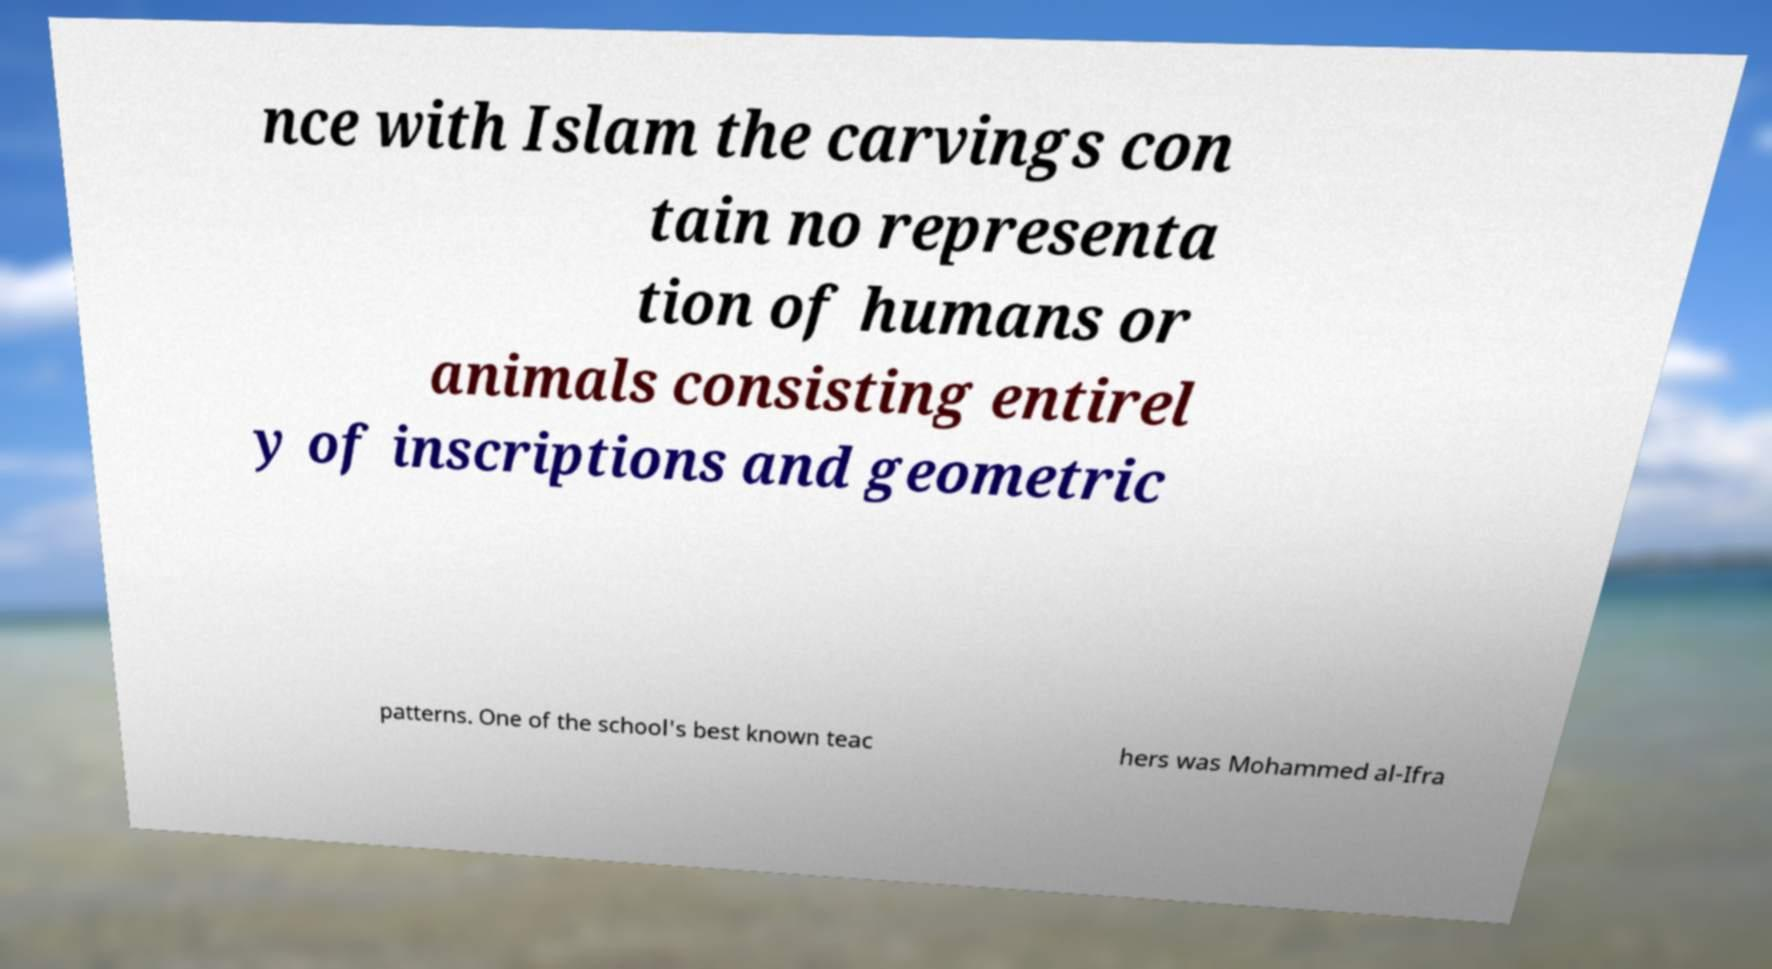Could you assist in decoding the text presented in this image and type it out clearly? nce with Islam the carvings con tain no representa tion of humans or animals consisting entirel y of inscriptions and geometric patterns. One of the school's best known teac hers was Mohammed al-Ifra 